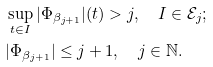Convert formula to latex. <formula><loc_0><loc_0><loc_500><loc_500>& \sup _ { t \in I } | \Phi _ { \beta _ { j + 1 } } | ( t ) > j , \quad I \in \mathcal { E } _ { j } ; \\ & | \Phi _ { \beta _ { j + 1 } } | \leq j + 1 , \quad j \in \mathbb { N } .</formula> 